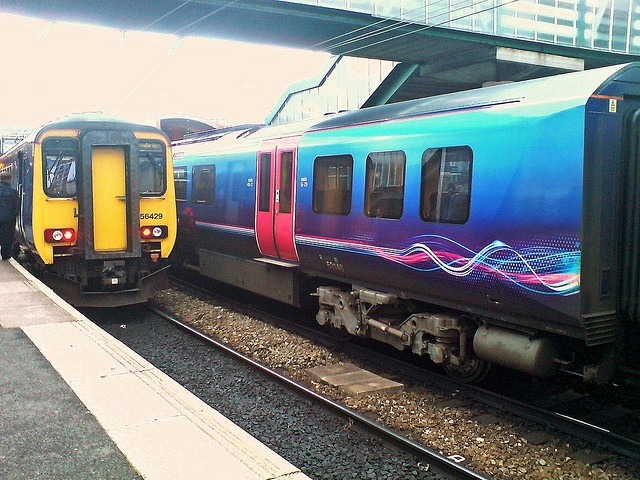Describe the objects in this image and their specific colors. I can see train in gray, black, ivory, and navy tones, train in gray, black, and gold tones, and people in gray, black, navy, and blue tones in this image. 